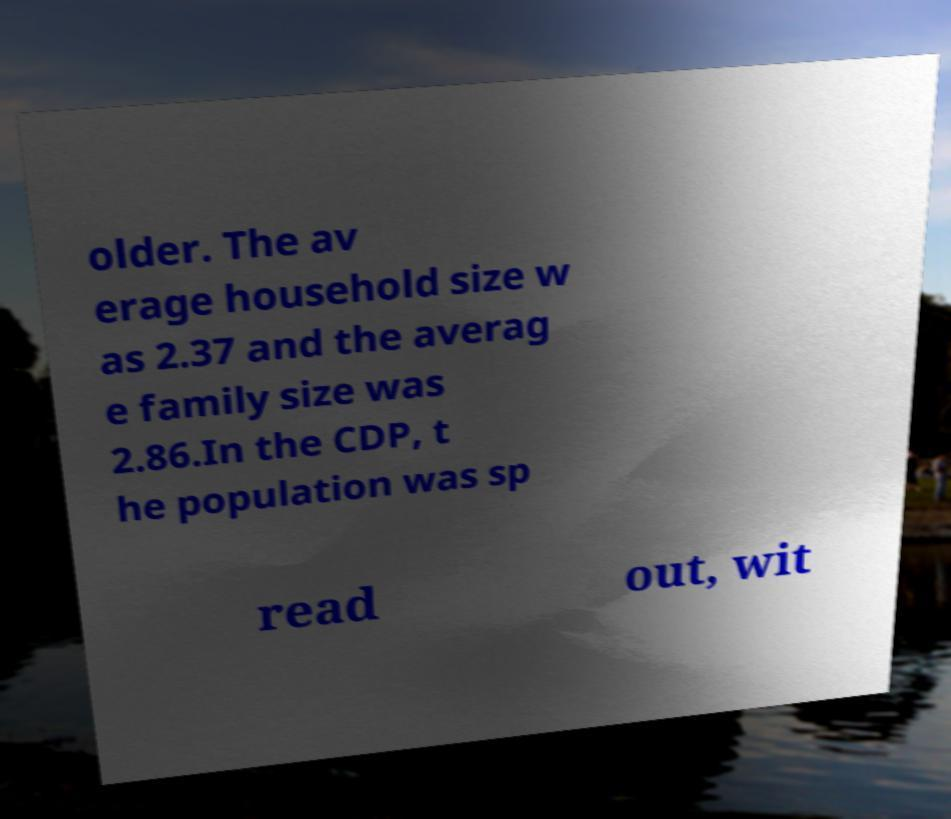Can you accurately transcribe the text from the provided image for me? older. The av erage household size w as 2.37 and the averag e family size was 2.86.In the CDP, t he population was sp read out, wit 